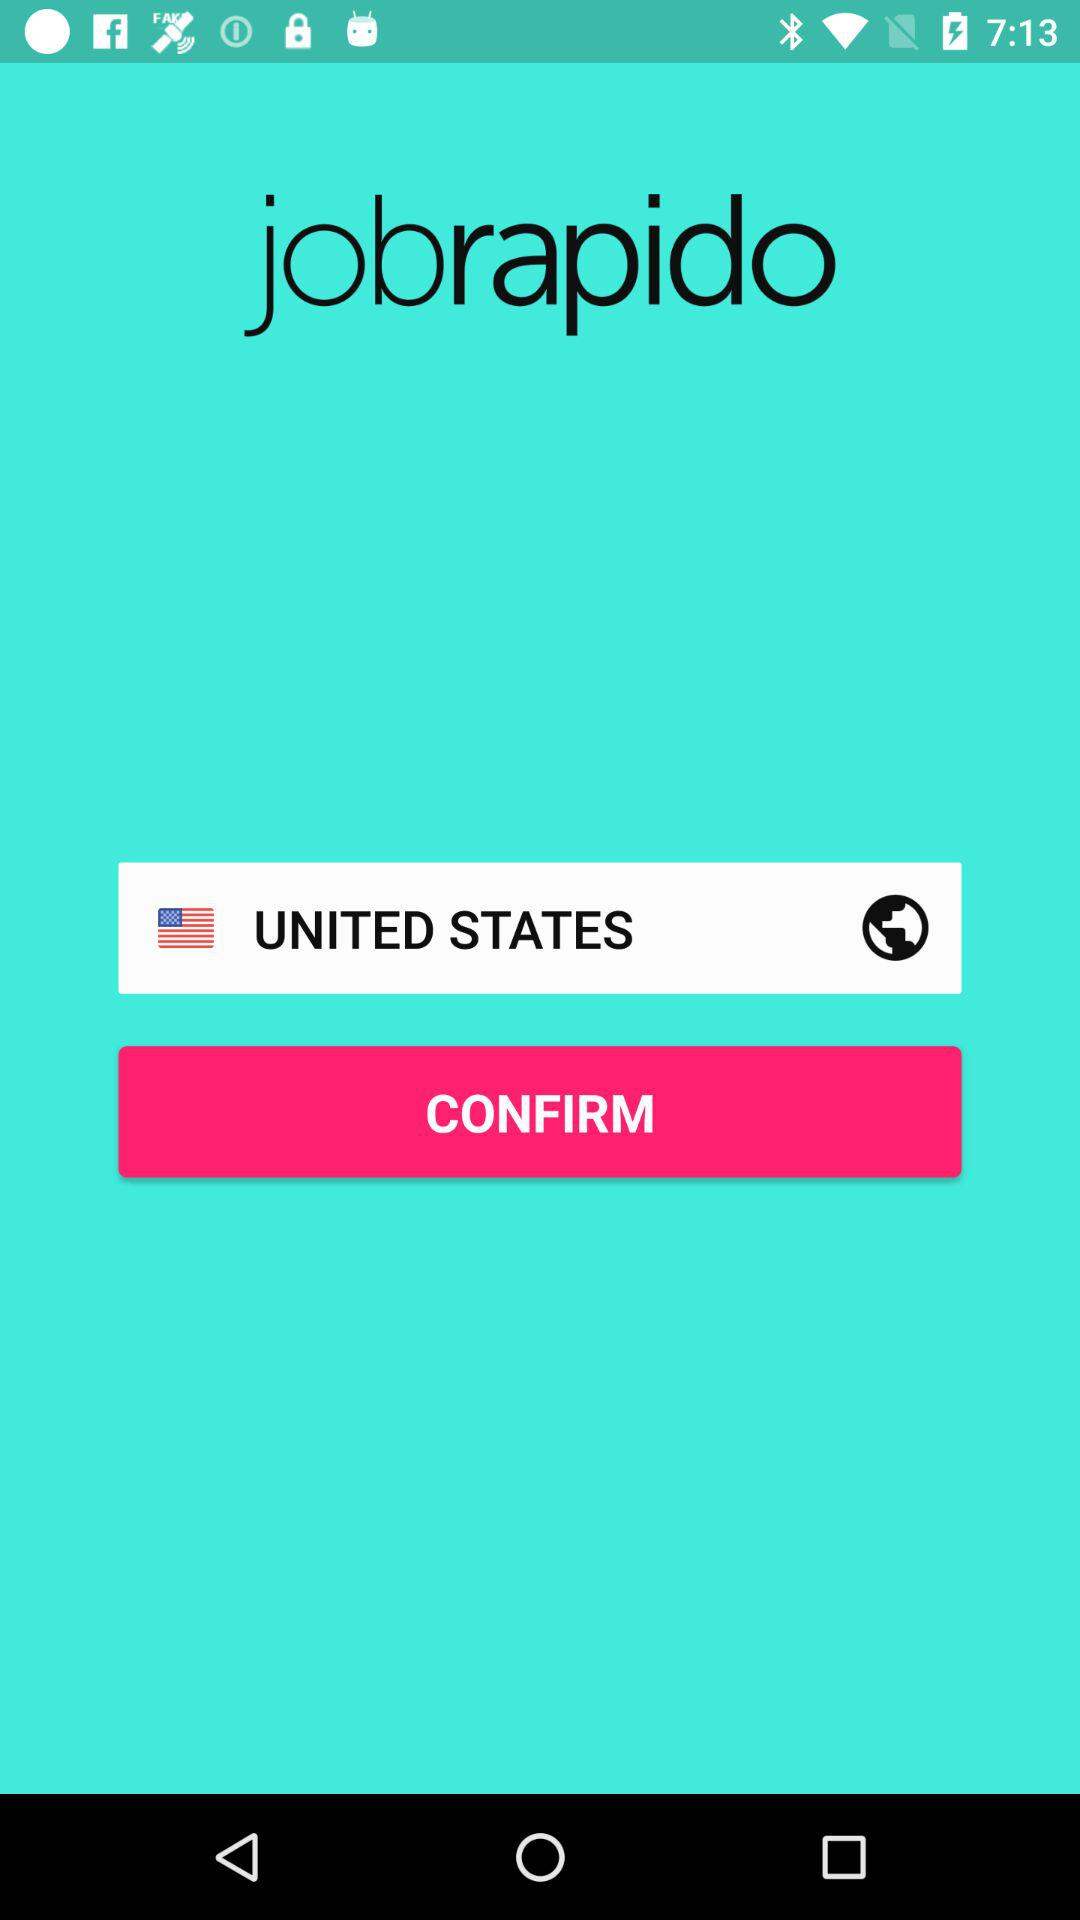Which country is selected? The selected country is the United States. 